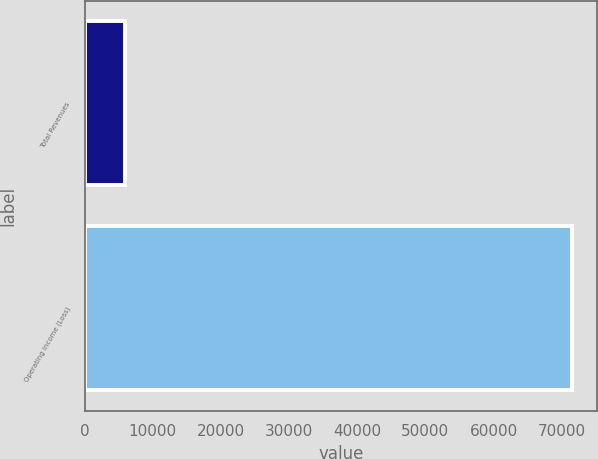Convert chart. <chart><loc_0><loc_0><loc_500><loc_500><bar_chart><fcel>Total Revenues<fcel>Operating Income (Loss)<nl><fcel>5950<fcel>71556<nl></chart> 